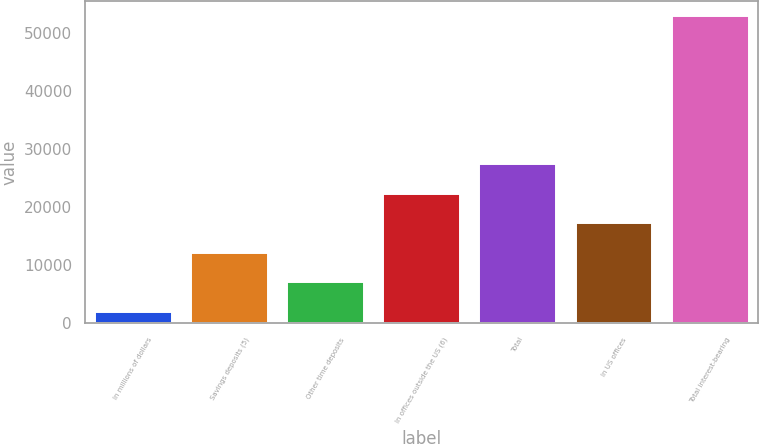<chart> <loc_0><loc_0><loc_500><loc_500><bar_chart><fcel>In millions of dollars<fcel>Savings deposits (5)<fcel>Other time deposits<fcel>In offices outside the US (6)<fcel>Total<fcel>In US offices<fcel>Total interest-bearing<nl><fcel>2008<fcel>12199<fcel>7103.5<fcel>22390<fcel>27485.5<fcel>17294.5<fcel>52963<nl></chart> 